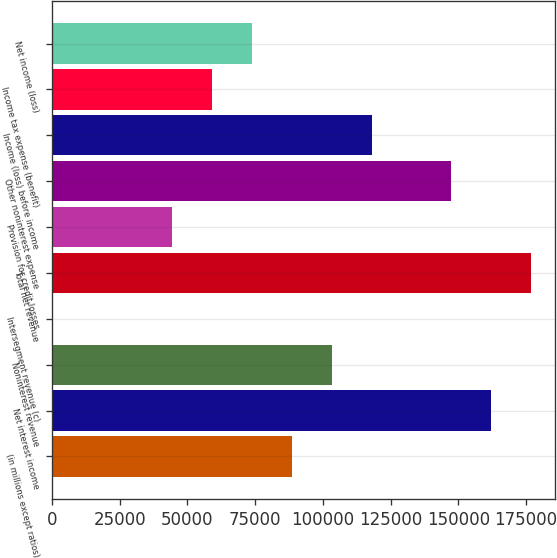Convert chart to OTSL. <chart><loc_0><loc_0><loc_500><loc_500><bar_chart><fcel>(in millions except ratios)<fcel>Net interest income<fcel>Noninterest revenue<fcel>Intersegment revenue (c)<fcel>Total net revenue<fcel>Provision for credit losses<fcel>Other noninterest expense<fcel>Income (loss) before income<fcel>Income tax expense (benefit)<fcel>Net income (loss)<nl><fcel>88470.6<fcel>162176<fcel>103212<fcel>24<fcel>176917<fcel>44247.3<fcel>147435<fcel>117953<fcel>58988.4<fcel>73729.5<nl></chart> 